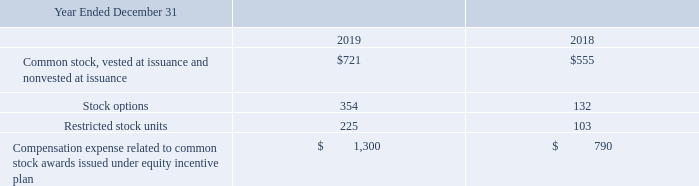Equity Incentive Plan
Our board of directors administers the plan, determines vesting schedules on plan awards and may accelerate the vesting schedules for award recipients. The stock options granted under the plan have terms of up to 10 years. As of December 31, 2019, awards for the purchase of 4,236,719 shares have been granted and remain outstanding (common stock options, common stock and restricted stock units) and 2,063,281 shares are reserved for future grants under the 2014 Plan.
Share-based compensation expenses related to stock options, stock and restricted stock units issued to employees and directors are included in selling, general and administrative expenses. The following table provides a detail of share-based compensation expense (in thousands).
What are the respective values of stock options in 2018 and 2019?
Answer scale should be: thousand. 132, 354. What are the respective values of restricted stock units  in 2018 and 2019?
Answer scale should be: thousand. 103, 225. What are the respective values of common stock in 2018 and 2019?
Answer scale should be: thousand. $555, $721. What is the change in the common stock value between 2018 and 2019?
Answer scale should be: thousand. 721 - 555 
Answer: 166. What is the total value of stock options in 2018 and 2019?
Answer scale should be: thousand. 354 + 132 
Answer: 486. What is the average value of stock options in 2018 and 2019?
Answer scale should be: thousand. (354 + 132)/2 
Answer: 243. 